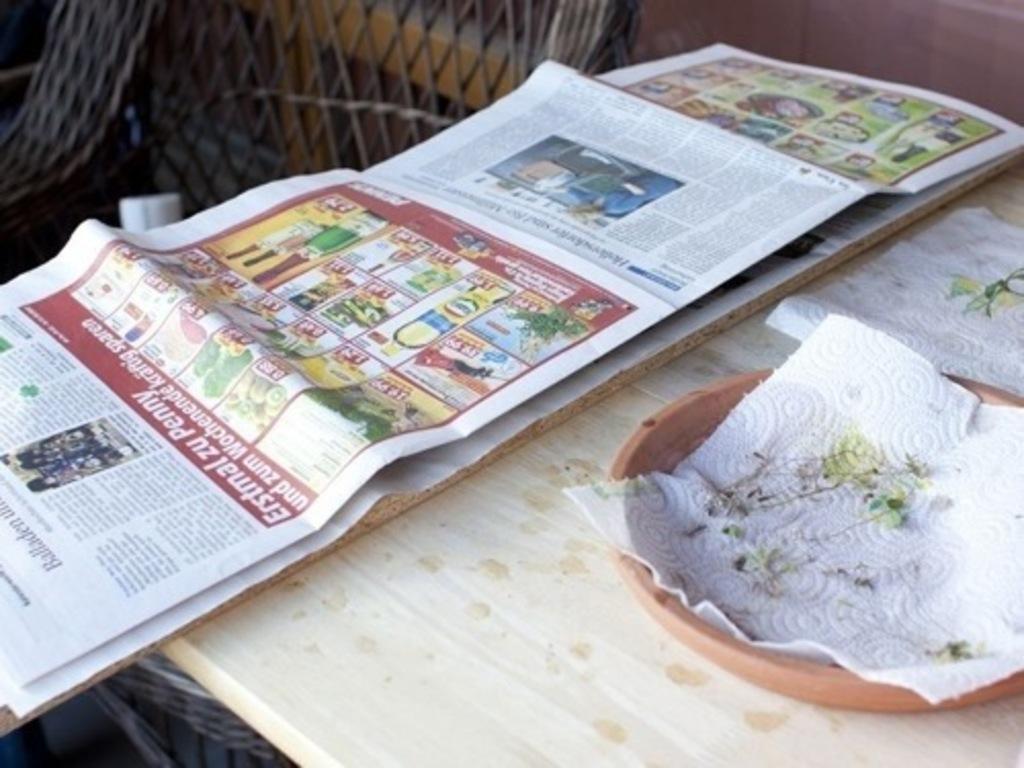Please provide a concise description of this image. In this image, we can see a newspaper, a bowl and some tissues are placed on the table. In the background, there is a chair and a wall. 